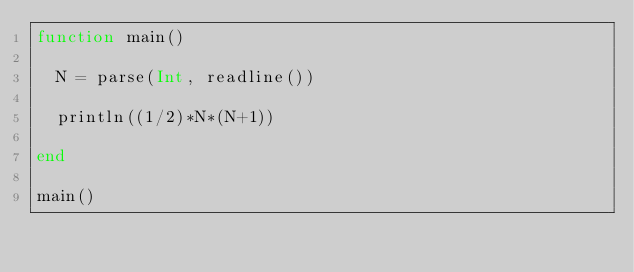<code> <loc_0><loc_0><loc_500><loc_500><_Julia_>function main()
  
  N = parse(Int, readline())
  
  println((1/2)*N*(N+1))
  
end

main()</code> 